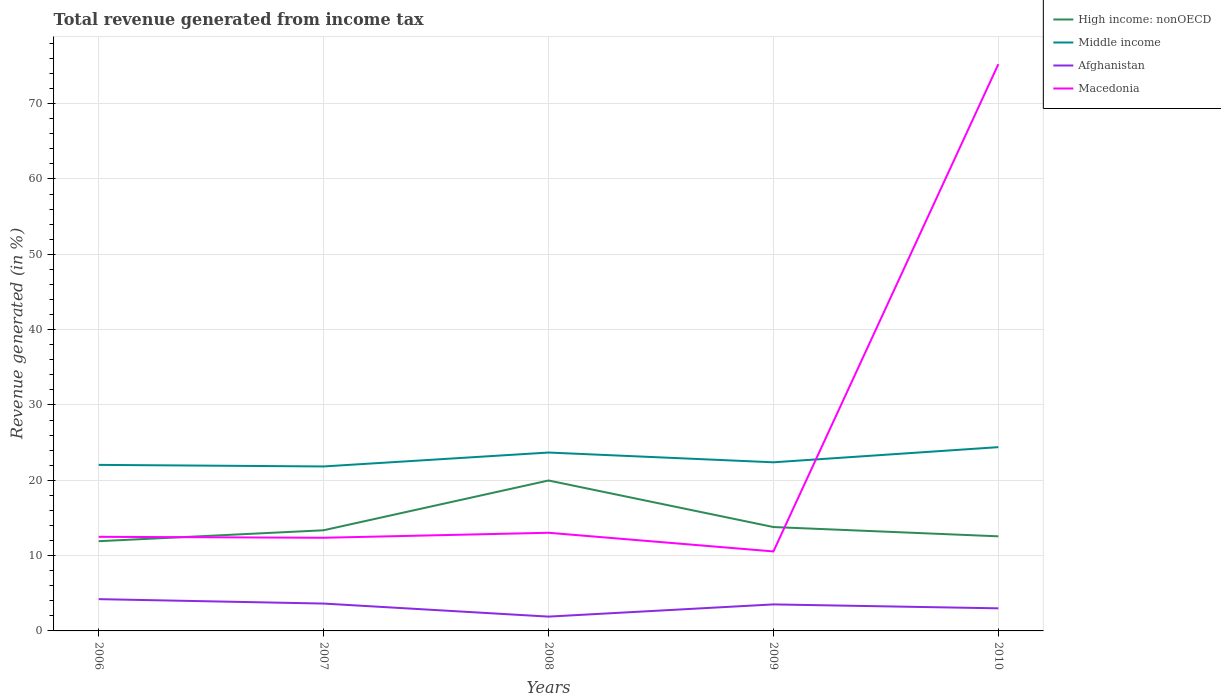Does the line corresponding to Afghanistan intersect with the line corresponding to Macedonia?
Your answer should be very brief. No. Across all years, what is the maximum total revenue generated in Afghanistan?
Your answer should be compact. 1.9. What is the total total revenue generated in Macedonia in the graph?
Offer a very short reply. 0.13. What is the difference between the highest and the second highest total revenue generated in Middle income?
Make the answer very short. 2.56. How many years are there in the graph?
Your answer should be very brief. 5. Are the values on the major ticks of Y-axis written in scientific E-notation?
Your answer should be compact. No. Does the graph contain grids?
Offer a terse response. Yes. How many legend labels are there?
Provide a short and direct response. 4. How are the legend labels stacked?
Offer a terse response. Vertical. What is the title of the graph?
Give a very brief answer. Total revenue generated from income tax. Does "Cabo Verde" appear as one of the legend labels in the graph?
Your response must be concise. No. What is the label or title of the X-axis?
Your answer should be very brief. Years. What is the label or title of the Y-axis?
Give a very brief answer. Revenue generated (in %). What is the Revenue generated (in %) in High income: nonOECD in 2006?
Offer a very short reply. 11.91. What is the Revenue generated (in %) in Middle income in 2006?
Your answer should be compact. 22.04. What is the Revenue generated (in %) of Afghanistan in 2006?
Your answer should be compact. 4.22. What is the Revenue generated (in %) of Macedonia in 2006?
Offer a very short reply. 12.49. What is the Revenue generated (in %) in High income: nonOECD in 2007?
Provide a succinct answer. 13.36. What is the Revenue generated (in %) of Middle income in 2007?
Keep it short and to the point. 21.84. What is the Revenue generated (in %) of Afghanistan in 2007?
Provide a succinct answer. 3.63. What is the Revenue generated (in %) of Macedonia in 2007?
Provide a short and direct response. 12.37. What is the Revenue generated (in %) of High income: nonOECD in 2008?
Your answer should be very brief. 19.97. What is the Revenue generated (in %) in Middle income in 2008?
Ensure brevity in your answer.  23.68. What is the Revenue generated (in %) of Afghanistan in 2008?
Your answer should be very brief. 1.9. What is the Revenue generated (in %) in Macedonia in 2008?
Provide a short and direct response. 13.03. What is the Revenue generated (in %) in High income: nonOECD in 2009?
Your response must be concise. 13.79. What is the Revenue generated (in %) of Middle income in 2009?
Offer a terse response. 22.39. What is the Revenue generated (in %) of Afghanistan in 2009?
Provide a short and direct response. 3.52. What is the Revenue generated (in %) of Macedonia in 2009?
Your answer should be very brief. 10.55. What is the Revenue generated (in %) in High income: nonOECD in 2010?
Offer a very short reply. 12.56. What is the Revenue generated (in %) of Middle income in 2010?
Your answer should be very brief. 24.4. What is the Revenue generated (in %) in Afghanistan in 2010?
Your answer should be very brief. 3. What is the Revenue generated (in %) in Macedonia in 2010?
Offer a very short reply. 75.24. Across all years, what is the maximum Revenue generated (in %) of High income: nonOECD?
Give a very brief answer. 19.97. Across all years, what is the maximum Revenue generated (in %) of Middle income?
Your response must be concise. 24.4. Across all years, what is the maximum Revenue generated (in %) in Afghanistan?
Give a very brief answer. 4.22. Across all years, what is the maximum Revenue generated (in %) of Macedonia?
Your answer should be very brief. 75.24. Across all years, what is the minimum Revenue generated (in %) in High income: nonOECD?
Give a very brief answer. 11.91. Across all years, what is the minimum Revenue generated (in %) of Middle income?
Ensure brevity in your answer.  21.84. Across all years, what is the minimum Revenue generated (in %) in Afghanistan?
Provide a short and direct response. 1.9. Across all years, what is the minimum Revenue generated (in %) of Macedonia?
Your answer should be compact. 10.55. What is the total Revenue generated (in %) in High income: nonOECD in the graph?
Provide a short and direct response. 71.6. What is the total Revenue generated (in %) of Middle income in the graph?
Provide a short and direct response. 114.35. What is the total Revenue generated (in %) of Afghanistan in the graph?
Your answer should be very brief. 16.27. What is the total Revenue generated (in %) in Macedonia in the graph?
Keep it short and to the point. 123.68. What is the difference between the Revenue generated (in %) of High income: nonOECD in 2006 and that in 2007?
Ensure brevity in your answer.  -1.45. What is the difference between the Revenue generated (in %) of Middle income in 2006 and that in 2007?
Provide a succinct answer. 0.21. What is the difference between the Revenue generated (in %) of Afghanistan in 2006 and that in 2007?
Keep it short and to the point. 0.59. What is the difference between the Revenue generated (in %) in Macedonia in 2006 and that in 2007?
Your response must be concise. 0.13. What is the difference between the Revenue generated (in %) in High income: nonOECD in 2006 and that in 2008?
Your response must be concise. -8.06. What is the difference between the Revenue generated (in %) in Middle income in 2006 and that in 2008?
Your answer should be very brief. -1.64. What is the difference between the Revenue generated (in %) of Afghanistan in 2006 and that in 2008?
Your answer should be compact. 2.32. What is the difference between the Revenue generated (in %) in Macedonia in 2006 and that in 2008?
Ensure brevity in your answer.  -0.54. What is the difference between the Revenue generated (in %) of High income: nonOECD in 2006 and that in 2009?
Provide a short and direct response. -1.88. What is the difference between the Revenue generated (in %) of Middle income in 2006 and that in 2009?
Offer a terse response. -0.34. What is the difference between the Revenue generated (in %) of Afghanistan in 2006 and that in 2009?
Ensure brevity in your answer.  0.7. What is the difference between the Revenue generated (in %) of Macedonia in 2006 and that in 2009?
Your answer should be compact. 1.94. What is the difference between the Revenue generated (in %) in High income: nonOECD in 2006 and that in 2010?
Offer a very short reply. -0.65. What is the difference between the Revenue generated (in %) in Middle income in 2006 and that in 2010?
Provide a short and direct response. -2.35. What is the difference between the Revenue generated (in %) of Afghanistan in 2006 and that in 2010?
Provide a short and direct response. 1.22. What is the difference between the Revenue generated (in %) of Macedonia in 2006 and that in 2010?
Offer a very short reply. -62.74. What is the difference between the Revenue generated (in %) of High income: nonOECD in 2007 and that in 2008?
Provide a short and direct response. -6.61. What is the difference between the Revenue generated (in %) of Middle income in 2007 and that in 2008?
Give a very brief answer. -1.85. What is the difference between the Revenue generated (in %) of Afghanistan in 2007 and that in 2008?
Keep it short and to the point. 1.73. What is the difference between the Revenue generated (in %) of Macedonia in 2007 and that in 2008?
Give a very brief answer. -0.66. What is the difference between the Revenue generated (in %) in High income: nonOECD in 2007 and that in 2009?
Give a very brief answer. -0.43. What is the difference between the Revenue generated (in %) of Middle income in 2007 and that in 2009?
Give a very brief answer. -0.55. What is the difference between the Revenue generated (in %) of Afghanistan in 2007 and that in 2009?
Provide a succinct answer. 0.11. What is the difference between the Revenue generated (in %) of Macedonia in 2007 and that in 2009?
Provide a succinct answer. 1.81. What is the difference between the Revenue generated (in %) of High income: nonOECD in 2007 and that in 2010?
Provide a short and direct response. 0.8. What is the difference between the Revenue generated (in %) in Middle income in 2007 and that in 2010?
Offer a terse response. -2.56. What is the difference between the Revenue generated (in %) in Afghanistan in 2007 and that in 2010?
Ensure brevity in your answer.  0.63. What is the difference between the Revenue generated (in %) of Macedonia in 2007 and that in 2010?
Give a very brief answer. -62.87. What is the difference between the Revenue generated (in %) in High income: nonOECD in 2008 and that in 2009?
Your answer should be very brief. 6.18. What is the difference between the Revenue generated (in %) in Middle income in 2008 and that in 2009?
Keep it short and to the point. 1.3. What is the difference between the Revenue generated (in %) in Afghanistan in 2008 and that in 2009?
Your answer should be very brief. -1.62. What is the difference between the Revenue generated (in %) in Macedonia in 2008 and that in 2009?
Keep it short and to the point. 2.48. What is the difference between the Revenue generated (in %) in High income: nonOECD in 2008 and that in 2010?
Your answer should be very brief. 7.41. What is the difference between the Revenue generated (in %) in Middle income in 2008 and that in 2010?
Keep it short and to the point. -0.72. What is the difference between the Revenue generated (in %) in Afghanistan in 2008 and that in 2010?
Offer a terse response. -1.1. What is the difference between the Revenue generated (in %) in Macedonia in 2008 and that in 2010?
Your answer should be compact. -62.21. What is the difference between the Revenue generated (in %) in High income: nonOECD in 2009 and that in 2010?
Offer a very short reply. 1.23. What is the difference between the Revenue generated (in %) of Middle income in 2009 and that in 2010?
Offer a terse response. -2.01. What is the difference between the Revenue generated (in %) of Afghanistan in 2009 and that in 2010?
Your answer should be compact. 0.52. What is the difference between the Revenue generated (in %) of Macedonia in 2009 and that in 2010?
Ensure brevity in your answer.  -64.68. What is the difference between the Revenue generated (in %) of High income: nonOECD in 2006 and the Revenue generated (in %) of Middle income in 2007?
Offer a very short reply. -9.92. What is the difference between the Revenue generated (in %) of High income: nonOECD in 2006 and the Revenue generated (in %) of Afghanistan in 2007?
Your answer should be compact. 8.28. What is the difference between the Revenue generated (in %) of High income: nonOECD in 2006 and the Revenue generated (in %) of Macedonia in 2007?
Give a very brief answer. -0.46. What is the difference between the Revenue generated (in %) in Middle income in 2006 and the Revenue generated (in %) in Afghanistan in 2007?
Provide a succinct answer. 18.41. What is the difference between the Revenue generated (in %) of Middle income in 2006 and the Revenue generated (in %) of Macedonia in 2007?
Provide a short and direct response. 9.68. What is the difference between the Revenue generated (in %) in Afghanistan in 2006 and the Revenue generated (in %) in Macedonia in 2007?
Ensure brevity in your answer.  -8.15. What is the difference between the Revenue generated (in %) in High income: nonOECD in 2006 and the Revenue generated (in %) in Middle income in 2008?
Your answer should be very brief. -11.77. What is the difference between the Revenue generated (in %) of High income: nonOECD in 2006 and the Revenue generated (in %) of Afghanistan in 2008?
Provide a short and direct response. 10.01. What is the difference between the Revenue generated (in %) of High income: nonOECD in 2006 and the Revenue generated (in %) of Macedonia in 2008?
Keep it short and to the point. -1.12. What is the difference between the Revenue generated (in %) of Middle income in 2006 and the Revenue generated (in %) of Afghanistan in 2008?
Offer a terse response. 20.14. What is the difference between the Revenue generated (in %) of Middle income in 2006 and the Revenue generated (in %) of Macedonia in 2008?
Provide a succinct answer. 9.01. What is the difference between the Revenue generated (in %) of Afghanistan in 2006 and the Revenue generated (in %) of Macedonia in 2008?
Offer a very short reply. -8.81. What is the difference between the Revenue generated (in %) of High income: nonOECD in 2006 and the Revenue generated (in %) of Middle income in 2009?
Provide a succinct answer. -10.48. What is the difference between the Revenue generated (in %) of High income: nonOECD in 2006 and the Revenue generated (in %) of Afghanistan in 2009?
Ensure brevity in your answer.  8.39. What is the difference between the Revenue generated (in %) in High income: nonOECD in 2006 and the Revenue generated (in %) in Macedonia in 2009?
Provide a succinct answer. 1.36. What is the difference between the Revenue generated (in %) of Middle income in 2006 and the Revenue generated (in %) of Afghanistan in 2009?
Ensure brevity in your answer.  18.52. What is the difference between the Revenue generated (in %) of Middle income in 2006 and the Revenue generated (in %) of Macedonia in 2009?
Give a very brief answer. 11.49. What is the difference between the Revenue generated (in %) of Afghanistan in 2006 and the Revenue generated (in %) of Macedonia in 2009?
Give a very brief answer. -6.33. What is the difference between the Revenue generated (in %) in High income: nonOECD in 2006 and the Revenue generated (in %) in Middle income in 2010?
Ensure brevity in your answer.  -12.49. What is the difference between the Revenue generated (in %) in High income: nonOECD in 2006 and the Revenue generated (in %) in Afghanistan in 2010?
Offer a very short reply. 8.91. What is the difference between the Revenue generated (in %) in High income: nonOECD in 2006 and the Revenue generated (in %) in Macedonia in 2010?
Your answer should be compact. -63.33. What is the difference between the Revenue generated (in %) in Middle income in 2006 and the Revenue generated (in %) in Afghanistan in 2010?
Your answer should be very brief. 19.05. What is the difference between the Revenue generated (in %) in Middle income in 2006 and the Revenue generated (in %) in Macedonia in 2010?
Ensure brevity in your answer.  -53.19. What is the difference between the Revenue generated (in %) of Afghanistan in 2006 and the Revenue generated (in %) of Macedonia in 2010?
Ensure brevity in your answer.  -71.02. What is the difference between the Revenue generated (in %) in High income: nonOECD in 2007 and the Revenue generated (in %) in Middle income in 2008?
Offer a very short reply. -10.32. What is the difference between the Revenue generated (in %) of High income: nonOECD in 2007 and the Revenue generated (in %) of Afghanistan in 2008?
Offer a very short reply. 11.46. What is the difference between the Revenue generated (in %) of High income: nonOECD in 2007 and the Revenue generated (in %) of Macedonia in 2008?
Offer a terse response. 0.33. What is the difference between the Revenue generated (in %) in Middle income in 2007 and the Revenue generated (in %) in Afghanistan in 2008?
Provide a succinct answer. 19.93. What is the difference between the Revenue generated (in %) in Middle income in 2007 and the Revenue generated (in %) in Macedonia in 2008?
Your response must be concise. 8.8. What is the difference between the Revenue generated (in %) in Afghanistan in 2007 and the Revenue generated (in %) in Macedonia in 2008?
Ensure brevity in your answer.  -9.4. What is the difference between the Revenue generated (in %) in High income: nonOECD in 2007 and the Revenue generated (in %) in Middle income in 2009?
Provide a succinct answer. -9.02. What is the difference between the Revenue generated (in %) in High income: nonOECD in 2007 and the Revenue generated (in %) in Afghanistan in 2009?
Offer a terse response. 9.84. What is the difference between the Revenue generated (in %) of High income: nonOECD in 2007 and the Revenue generated (in %) of Macedonia in 2009?
Your answer should be compact. 2.81. What is the difference between the Revenue generated (in %) of Middle income in 2007 and the Revenue generated (in %) of Afghanistan in 2009?
Your response must be concise. 18.32. What is the difference between the Revenue generated (in %) of Middle income in 2007 and the Revenue generated (in %) of Macedonia in 2009?
Make the answer very short. 11.28. What is the difference between the Revenue generated (in %) in Afghanistan in 2007 and the Revenue generated (in %) in Macedonia in 2009?
Your answer should be compact. -6.92. What is the difference between the Revenue generated (in %) of High income: nonOECD in 2007 and the Revenue generated (in %) of Middle income in 2010?
Offer a terse response. -11.04. What is the difference between the Revenue generated (in %) of High income: nonOECD in 2007 and the Revenue generated (in %) of Afghanistan in 2010?
Offer a very short reply. 10.36. What is the difference between the Revenue generated (in %) of High income: nonOECD in 2007 and the Revenue generated (in %) of Macedonia in 2010?
Provide a succinct answer. -61.87. What is the difference between the Revenue generated (in %) in Middle income in 2007 and the Revenue generated (in %) in Afghanistan in 2010?
Your response must be concise. 18.84. What is the difference between the Revenue generated (in %) in Middle income in 2007 and the Revenue generated (in %) in Macedonia in 2010?
Make the answer very short. -53.4. What is the difference between the Revenue generated (in %) in Afghanistan in 2007 and the Revenue generated (in %) in Macedonia in 2010?
Provide a short and direct response. -71.61. What is the difference between the Revenue generated (in %) of High income: nonOECD in 2008 and the Revenue generated (in %) of Middle income in 2009?
Provide a succinct answer. -2.42. What is the difference between the Revenue generated (in %) of High income: nonOECD in 2008 and the Revenue generated (in %) of Afghanistan in 2009?
Give a very brief answer. 16.45. What is the difference between the Revenue generated (in %) of High income: nonOECD in 2008 and the Revenue generated (in %) of Macedonia in 2009?
Provide a short and direct response. 9.42. What is the difference between the Revenue generated (in %) of Middle income in 2008 and the Revenue generated (in %) of Afghanistan in 2009?
Provide a succinct answer. 20.16. What is the difference between the Revenue generated (in %) of Middle income in 2008 and the Revenue generated (in %) of Macedonia in 2009?
Your response must be concise. 13.13. What is the difference between the Revenue generated (in %) of Afghanistan in 2008 and the Revenue generated (in %) of Macedonia in 2009?
Make the answer very short. -8.65. What is the difference between the Revenue generated (in %) of High income: nonOECD in 2008 and the Revenue generated (in %) of Middle income in 2010?
Make the answer very short. -4.43. What is the difference between the Revenue generated (in %) in High income: nonOECD in 2008 and the Revenue generated (in %) in Afghanistan in 2010?
Provide a succinct answer. 16.97. What is the difference between the Revenue generated (in %) in High income: nonOECD in 2008 and the Revenue generated (in %) in Macedonia in 2010?
Give a very brief answer. -55.27. What is the difference between the Revenue generated (in %) in Middle income in 2008 and the Revenue generated (in %) in Afghanistan in 2010?
Provide a succinct answer. 20.68. What is the difference between the Revenue generated (in %) of Middle income in 2008 and the Revenue generated (in %) of Macedonia in 2010?
Provide a succinct answer. -51.55. What is the difference between the Revenue generated (in %) of Afghanistan in 2008 and the Revenue generated (in %) of Macedonia in 2010?
Keep it short and to the point. -73.34. What is the difference between the Revenue generated (in %) of High income: nonOECD in 2009 and the Revenue generated (in %) of Middle income in 2010?
Ensure brevity in your answer.  -10.61. What is the difference between the Revenue generated (in %) of High income: nonOECD in 2009 and the Revenue generated (in %) of Afghanistan in 2010?
Ensure brevity in your answer.  10.79. What is the difference between the Revenue generated (in %) of High income: nonOECD in 2009 and the Revenue generated (in %) of Macedonia in 2010?
Keep it short and to the point. -61.45. What is the difference between the Revenue generated (in %) in Middle income in 2009 and the Revenue generated (in %) in Afghanistan in 2010?
Ensure brevity in your answer.  19.39. What is the difference between the Revenue generated (in %) of Middle income in 2009 and the Revenue generated (in %) of Macedonia in 2010?
Offer a very short reply. -52.85. What is the difference between the Revenue generated (in %) of Afghanistan in 2009 and the Revenue generated (in %) of Macedonia in 2010?
Ensure brevity in your answer.  -71.72. What is the average Revenue generated (in %) of High income: nonOECD per year?
Offer a terse response. 14.32. What is the average Revenue generated (in %) in Middle income per year?
Provide a short and direct response. 22.87. What is the average Revenue generated (in %) of Afghanistan per year?
Your answer should be compact. 3.25. What is the average Revenue generated (in %) of Macedonia per year?
Your response must be concise. 24.74. In the year 2006, what is the difference between the Revenue generated (in %) of High income: nonOECD and Revenue generated (in %) of Middle income?
Your response must be concise. -10.13. In the year 2006, what is the difference between the Revenue generated (in %) in High income: nonOECD and Revenue generated (in %) in Afghanistan?
Keep it short and to the point. 7.69. In the year 2006, what is the difference between the Revenue generated (in %) in High income: nonOECD and Revenue generated (in %) in Macedonia?
Offer a terse response. -0.58. In the year 2006, what is the difference between the Revenue generated (in %) of Middle income and Revenue generated (in %) of Afghanistan?
Give a very brief answer. 17.83. In the year 2006, what is the difference between the Revenue generated (in %) in Middle income and Revenue generated (in %) in Macedonia?
Give a very brief answer. 9.55. In the year 2006, what is the difference between the Revenue generated (in %) of Afghanistan and Revenue generated (in %) of Macedonia?
Provide a succinct answer. -8.28. In the year 2007, what is the difference between the Revenue generated (in %) in High income: nonOECD and Revenue generated (in %) in Middle income?
Make the answer very short. -8.47. In the year 2007, what is the difference between the Revenue generated (in %) in High income: nonOECD and Revenue generated (in %) in Afghanistan?
Make the answer very short. 9.73. In the year 2007, what is the difference between the Revenue generated (in %) of Middle income and Revenue generated (in %) of Afghanistan?
Provide a short and direct response. 18.2. In the year 2007, what is the difference between the Revenue generated (in %) in Middle income and Revenue generated (in %) in Macedonia?
Give a very brief answer. 9.47. In the year 2007, what is the difference between the Revenue generated (in %) in Afghanistan and Revenue generated (in %) in Macedonia?
Keep it short and to the point. -8.74. In the year 2008, what is the difference between the Revenue generated (in %) of High income: nonOECD and Revenue generated (in %) of Middle income?
Offer a terse response. -3.71. In the year 2008, what is the difference between the Revenue generated (in %) in High income: nonOECD and Revenue generated (in %) in Afghanistan?
Your answer should be compact. 18.07. In the year 2008, what is the difference between the Revenue generated (in %) of High income: nonOECD and Revenue generated (in %) of Macedonia?
Your response must be concise. 6.94. In the year 2008, what is the difference between the Revenue generated (in %) in Middle income and Revenue generated (in %) in Afghanistan?
Give a very brief answer. 21.78. In the year 2008, what is the difference between the Revenue generated (in %) in Middle income and Revenue generated (in %) in Macedonia?
Make the answer very short. 10.65. In the year 2008, what is the difference between the Revenue generated (in %) in Afghanistan and Revenue generated (in %) in Macedonia?
Keep it short and to the point. -11.13. In the year 2009, what is the difference between the Revenue generated (in %) in High income: nonOECD and Revenue generated (in %) in Middle income?
Offer a terse response. -8.6. In the year 2009, what is the difference between the Revenue generated (in %) in High income: nonOECD and Revenue generated (in %) in Afghanistan?
Make the answer very short. 10.27. In the year 2009, what is the difference between the Revenue generated (in %) in High income: nonOECD and Revenue generated (in %) in Macedonia?
Provide a succinct answer. 3.24. In the year 2009, what is the difference between the Revenue generated (in %) in Middle income and Revenue generated (in %) in Afghanistan?
Make the answer very short. 18.87. In the year 2009, what is the difference between the Revenue generated (in %) of Middle income and Revenue generated (in %) of Macedonia?
Offer a very short reply. 11.83. In the year 2009, what is the difference between the Revenue generated (in %) of Afghanistan and Revenue generated (in %) of Macedonia?
Provide a succinct answer. -7.03. In the year 2010, what is the difference between the Revenue generated (in %) of High income: nonOECD and Revenue generated (in %) of Middle income?
Make the answer very short. -11.84. In the year 2010, what is the difference between the Revenue generated (in %) in High income: nonOECD and Revenue generated (in %) in Afghanistan?
Provide a succinct answer. 9.56. In the year 2010, what is the difference between the Revenue generated (in %) in High income: nonOECD and Revenue generated (in %) in Macedonia?
Offer a very short reply. -62.68. In the year 2010, what is the difference between the Revenue generated (in %) of Middle income and Revenue generated (in %) of Afghanistan?
Make the answer very short. 21.4. In the year 2010, what is the difference between the Revenue generated (in %) of Middle income and Revenue generated (in %) of Macedonia?
Give a very brief answer. -50.84. In the year 2010, what is the difference between the Revenue generated (in %) in Afghanistan and Revenue generated (in %) in Macedonia?
Make the answer very short. -72.24. What is the ratio of the Revenue generated (in %) of High income: nonOECD in 2006 to that in 2007?
Offer a very short reply. 0.89. What is the ratio of the Revenue generated (in %) in Middle income in 2006 to that in 2007?
Offer a very short reply. 1.01. What is the ratio of the Revenue generated (in %) in Afghanistan in 2006 to that in 2007?
Give a very brief answer. 1.16. What is the ratio of the Revenue generated (in %) in Macedonia in 2006 to that in 2007?
Give a very brief answer. 1.01. What is the ratio of the Revenue generated (in %) of High income: nonOECD in 2006 to that in 2008?
Your answer should be very brief. 0.6. What is the ratio of the Revenue generated (in %) of Middle income in 2006 to that in 2008?
Your response must be concise. 0.93. What is the ratio of the Revenue generated (in %) in Afghanistan in 2006 to that in 2008?
Your response must be concise. 2.22. What is the ratio of the Revenue generated (in %) in Macedonia in 2006 to that in 2008?
Your answer should be very brief. 0.96. What is the ratio of the Revenue generated (in %) in High income: nonOECD in 2006 to that in 2009?
Give a very brief answer. 0.86. What is the ratio of the Revenue generated (in %) of Middle income in 2006 to that in 2009?
Offer a terse response. 0.98. What is the ratio of the Revenue generated (in %) in Afghanistan in 2006 to that in 2009?
Make the answer very short. 1.2. What is the ratio of the Revenue generated (in %) in Macedonia in 2006 to that in 2009?
Provide a succinct answer. 1.18. What is the ratio of the Revenue generated (in %) in High income: nonOECD in 2006 to that in 2010?
Your response must be concise. 0.95. What is the ratio of the Revenue generated (in %) in Middle income in 2006 to that in 2010?
Offer a terse response. 0.9. What is the ratio of the Revenue generated (in %) in Afghanistan in 2006 to that in 2010?
Provide a short and direct response. 1.41. What is the ratio of the Revenue generated (in %) in Macedonia in 2006 to that in 2010?
Provide a short and direct response. 0.17. What is the ratio of the Revenue generated (in %) of High income: nonOECD in 2007 to that in 2008?
Keep it short and to the point. 0.67. What is the ratio of the Revenue generated (in %) in Middle income in 2007 to that in 2008?
Give a very brief answer. 0.92. What is the ratio of the Revenue generated (in %) of Afghanistan in 2007 to that in 2008?
Provide a short and direct response. 1.91. What is the ratio of the Revenue generated (in %) of Macedonia in 2007 to that in 2008?
Give a very brief answer. 0.95. What is the ratio of the Revenue generated (in %) of High income: nonOECD in 2007 to that in 2009?
Your response must be concise. 0.97. What is the ratio of the Revenue generated (in %) in Middle income in 2007 to that in 2009?
Your response must be concise. 0.98. What is the ratio of the Revenue generated (in %) of Afghanistan in 2007 to that in 2009?
Keep it short and to the point. 1.03. What is the ratio of the Revenue generated (in %) in Macedonia in 2007 to that in 2009?
Give a very brief answer. 1.17. What is the ratio of the Revenue generated (in %) in High income: nonOECD in 2007 to that in 2010?
Make the answer very short. 1.06. What is the ratio of the Revenue generated (in %) in Middle income in 2007 to that in 2010?
Provide a short and direct response. 0.89. What is the ratio of the Revenue generated (in %) in Afghanistan in 2007 to that in 2010?
Ensure brevity in your answer.  1.21. What is the ratio of the Revenue generated (in %) of Macedonia in 2007 to that in 2010?
Your answer should be compact. 0.16. What is the ratio of the Revenue generated (in %) in High income: nonOECD in 2008 to that in 2009?
Offer a terse response. 1.45. What is the ratio of the Revenue generated (in %) of Middle income in 2008 to that in 2009?
Your answer should be compact. 1.06. What is the ratio of the Revenue generated (in %) of Afghanistan in 2008 to that in 2009?
Provide a short and direct response. 0.54. What is the ratio of the Revenue generated (in %) in Macedonia in 2008 to that in 2009?
Ensure brevity in your answer.  1.23. What is the ratio of the Revenue generated (in %) of High income: nonOECD in 2008 to that in 2010?
Provide a short and direct response. 1.59. What is the ratio of the Revenue generated (in %) of Middle income in 2008 to that in 2010?
Your response must be concise. 0.97. What is the ratio of the Revenue generated (in %) in Afghanistan in 2008 to that in 2010?
Your answer should be very brief. 0.63. What is the ratio of the Revenue generated (in %) in Macedonia in 2008 to that in 2010?
Your answer should be very brief. 0.17. What is the ratio of the Revenue generated (in %) of High income: nonOECD in 2009 to that in 2010?
Ensure brevity in your answer.  1.1. What is the ratio of the Revenue generated (in %) in Middle income in 2009 to that in 2010?
Make the answer very short. 0.92. What is the ratio of the Revenue generated (in %) of Afghanistan in 2009 to that in 2010?
Your answer should be compact. 1.17. What is the ratio of the Revenue generated (in %) of Macedonia in 2009 to that in 2010?
Your answer should be compact. 0.14. What is the difference between the highest and the second highest Revenue generated (in %) in High income: nonOECD?
Offer a very short reply. 6.18. What is the difference between the highest and the second highest Revenue generated (in %) of Middle income?
Provide a short and direct response. 0.72. What is the difference between the highest and the second highest Revenue generated (in %) of Afghanistan?
Your answer should be compact. 0.59. What is the difference between the highest and the second highest Revenue generated (in %) of Macedonia?
Your response must be concise. 62.21. What is the difference between the highest and the lowest Revenue generated (in %) in High income: nonOECD?
Keep it short and to the point. 8.06. What is the difference between the highest and the lowest Revenue generated (in %) in Middle income?
Make the answer very short. 2.56. What is the difference between the highest and the lowest Revenue generated (in %) of Afghanistan?
Your answer should be compact. 2.32. What is the difference between the highest and the lowest Revenue generated (in %) of Macedonia?
Your answer should be very brief. 64.68. 